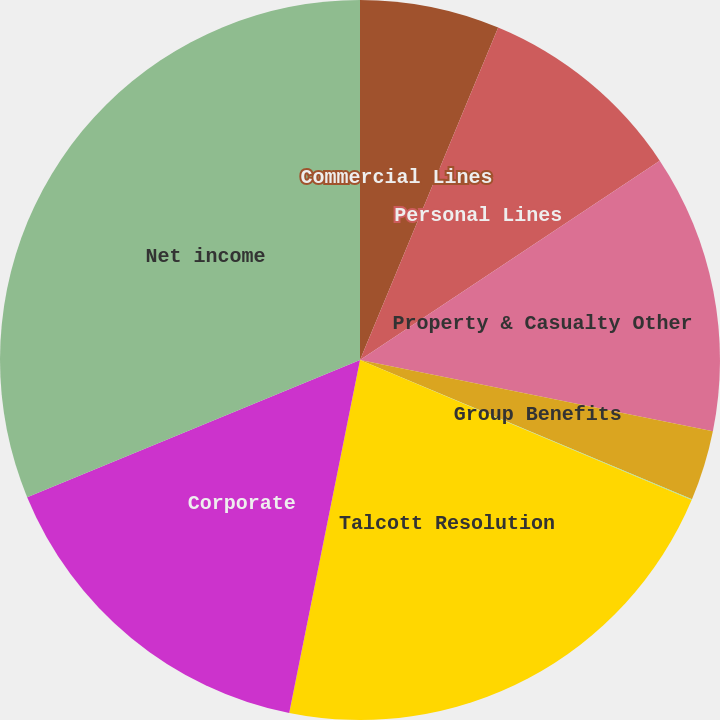Convert chart. <chart><loc_0><loc_0><loc_500><loc_500><pie_chart><fcel>Commercial Lines<fcel>Personal Lines<fcel>Property & Casualty Other<fcel>Group Benefits<fcel>Mutual Funds<fcel>Talcott Resolution<fcel>Corporate<fcel>Net income<nl><fcel>6.27%<fcel>9.39%<fcel>12.51%<fcel>3.15%<fcel>0.04%<fcel>21.79%<fcel>15.63%<fcel>31.22%<nl></chart> 